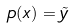<formula> <loc_0><loc_0><loc_500><loc_500>p ( x ) = \tilde { y }</formula> 